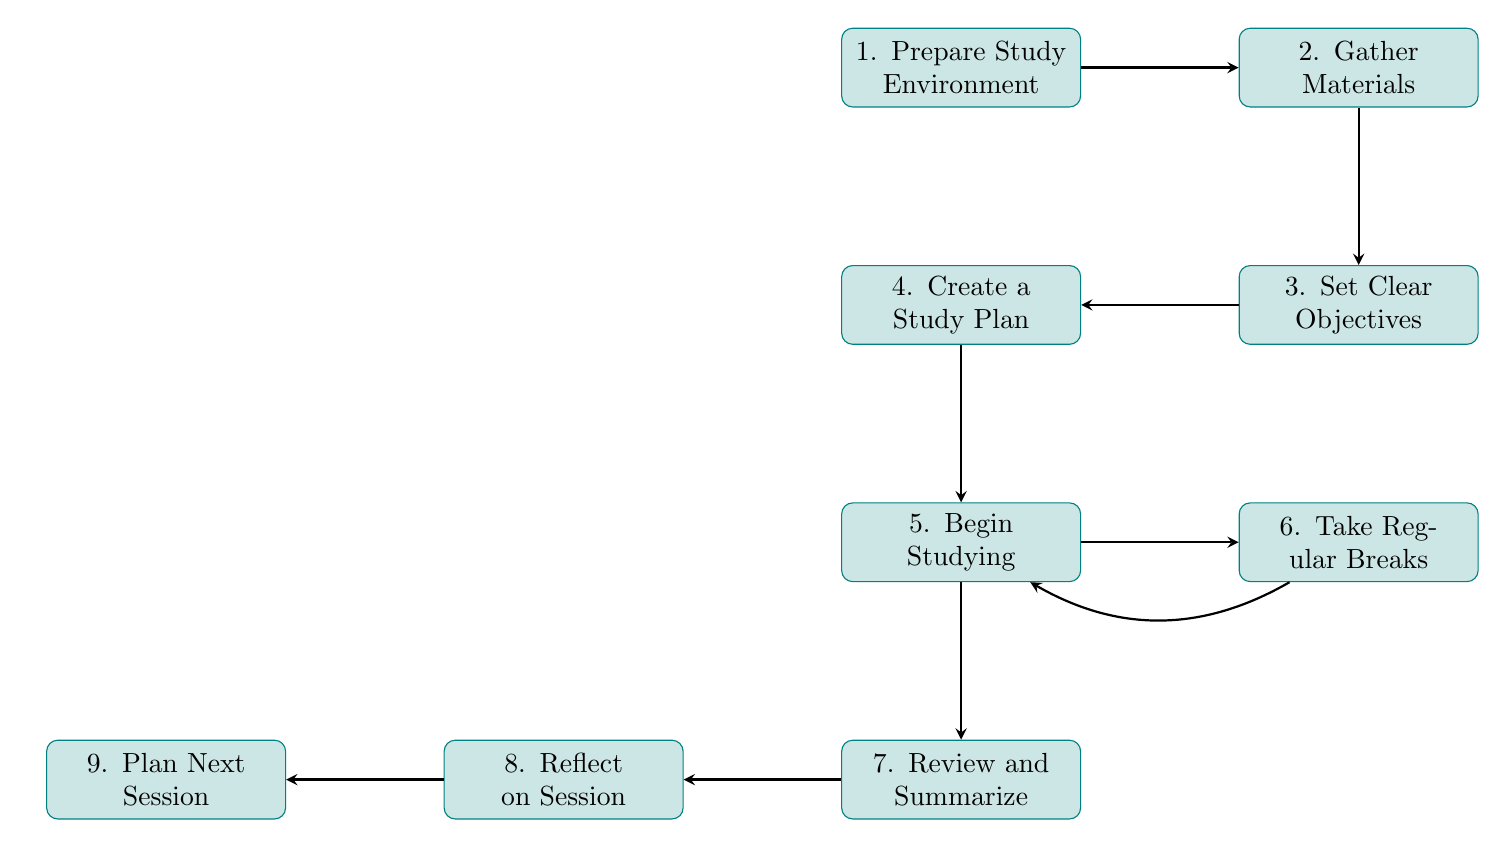What is the first step to complete a study session? The diagram shows that the first step is "Prepare Study Environment," which is the topmost node connected to the rest of the steps.
Answer: Prepare Study Environment How many nodes are in the diagram? By counting each unique process described in the nodes section, there are nine distinct nodes representing different steps in the study process.
Answer: Nine What follows after "Gather Materials"? The flow connects "Gather Materials" to "Set Clear Objectives" as the next step, indicating a direct progression in the study sequence.
Answer: Set Clear Objectives What step involves evaluating what was accomplished? Upon following the flow from the last steps, the "Reflect on Session" node involves evaluating what has been accomplished, as indicated in the diagram's sequence.
Answer: Reflect on Session Which step leads back to studying again? The diagram shows that "Take Regular Breaks" leads back to "Begin Studying," suggesting a loop for taking breaks and returning to study.
Answer: Begin Studying What are the last two steps in the flow? The final steps, as indicated by their positions in the diagram, are "Reflect on Session" followed by "Plan Next Session," showing the progression to evaluating and planning future study efforts.
Answer: Reflect on Session, Plan Next Session Which step is directly connected to "Review and Summarize"? According to the flow, "Review and Summarize" is directly connected to "Reflect on Session," indicating it comes before the reflection phase in the study process.
Answer: Reflect on Session What is the purpose of "Create a Study Plan"? "Create a Study Plan" is designed to divide study time into manageable segments, which is essential for maintaining focus and efficiency during the session.
Answer: Divide study time into manageable segments How does the flowchart suggest one should begin studying? The direction shows that one should "Begin Studying" with the "most challenging material first," emphasizing a strategy for effective learning when energy levels are high.
Answer: Most challenging material first 